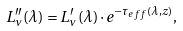<formula> <loc_0><loc_0><loc_500><loc_500>L ^ { \prime \prime } _ { \nu } { ( \lambda ) } = L ^ { \prime } _ { \nu } { ( \lambda ) } \cdot e ^ { - \tau _ { e f f } ( \lambda , z ) } ,</formula> 